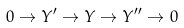Convert formula to latex. <formula><loc_0><loc_0><loc_500><loc_500>0 \rightarrow Y ^ { \prime } \rightarrow Y \rightarrow Y ^ { \prime \prime } \rightarrow 0</formula> 